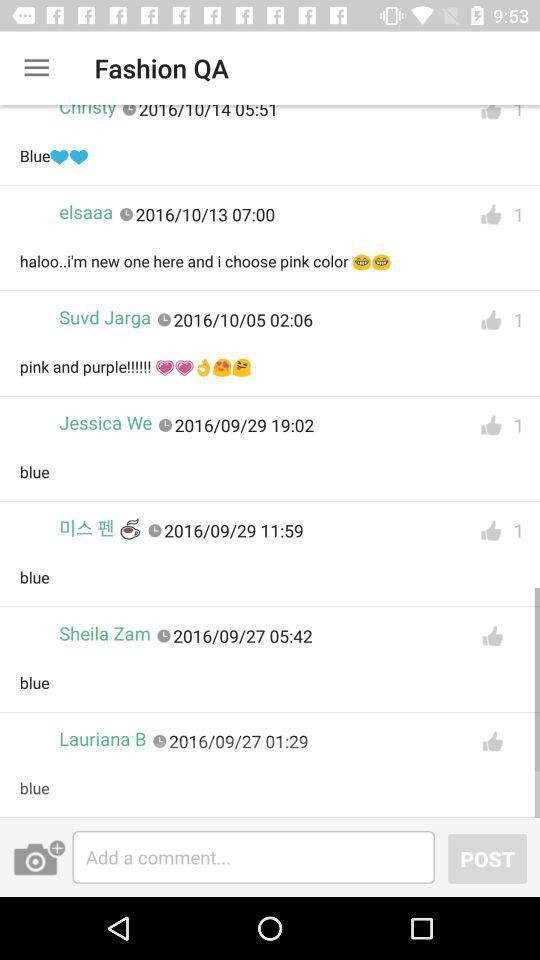What is the date of Jessica We's comment? The date is September 29, 2016. 